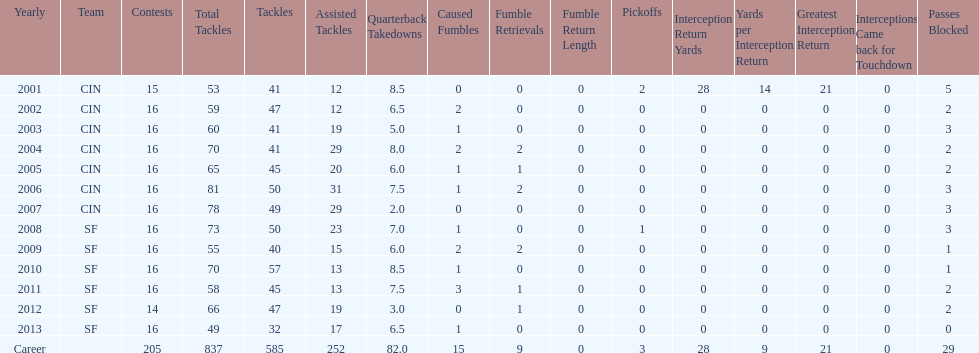How many sacks did this player have in his first five seasons? 34. 